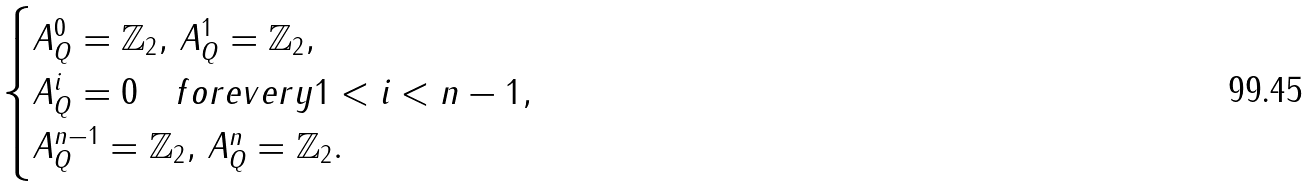<formula> <loc_0><loc_0><loc_500><loc_500>\begin{cases} A _ { Q } ^ { 0 } = \mathbb { Z } _ { 2 } , \, A _ { Q } ^ { 1 } = \mathbb { Z } _ { 2 } , \\ A _ { Q } ^ { i } = 0 \quad f o r e v e r y 1 < i < n - 1 , \\ A _ { Q } ^ { n - 1 } = \mathbb { Z } _ { 2 } , \, A _ { Q } ^ { n } = \mathbb { Z } _ { 2 } . \end{cases}</formula> 